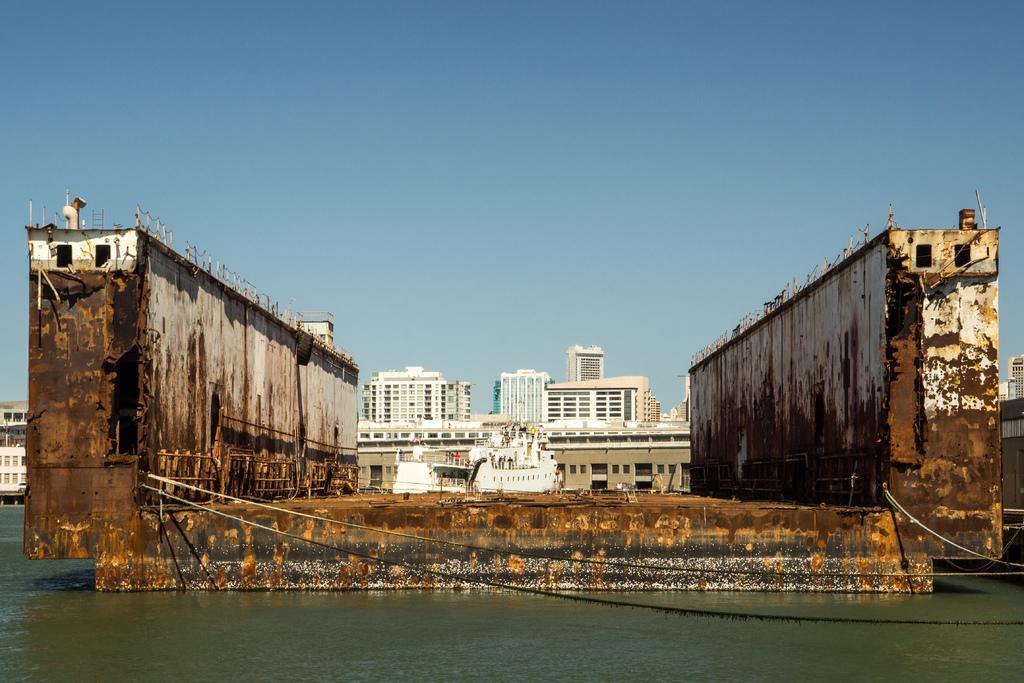Describe this image in one or two sentences. In this image we can see buildings, there are ships, also we can see the water, also we can see the sky. 